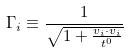Convert formula to latex. <formula><loc_0><loc_0><loc_500><loc_500>\Gamma _ { i } \equiv \frac { 1 } { \sqrt { 1 + \frac { v _ { i } \cdot v _ { i } } { t ^ { 0 } } } }</formula> 